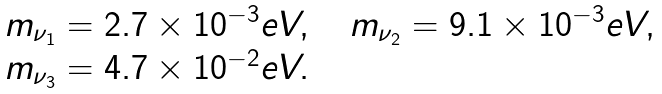Convert formula to latex. <formula><loc_0><loc_0><loc_500><loc_500>\begin{array} { l } m _ { \nu _ { 1 } } = 2 . 7 \times 1 0 ^ { - 3 } e V , \quad m _ { \nu _ { 2 } } = 9 . 1 \times 1 0 ^ { - 3 } e V , \\ m _ { \nu _ { 3 } } = 4 . 7 \times 1 0 ^ { - 2 } e V . \end{array}</formula> 